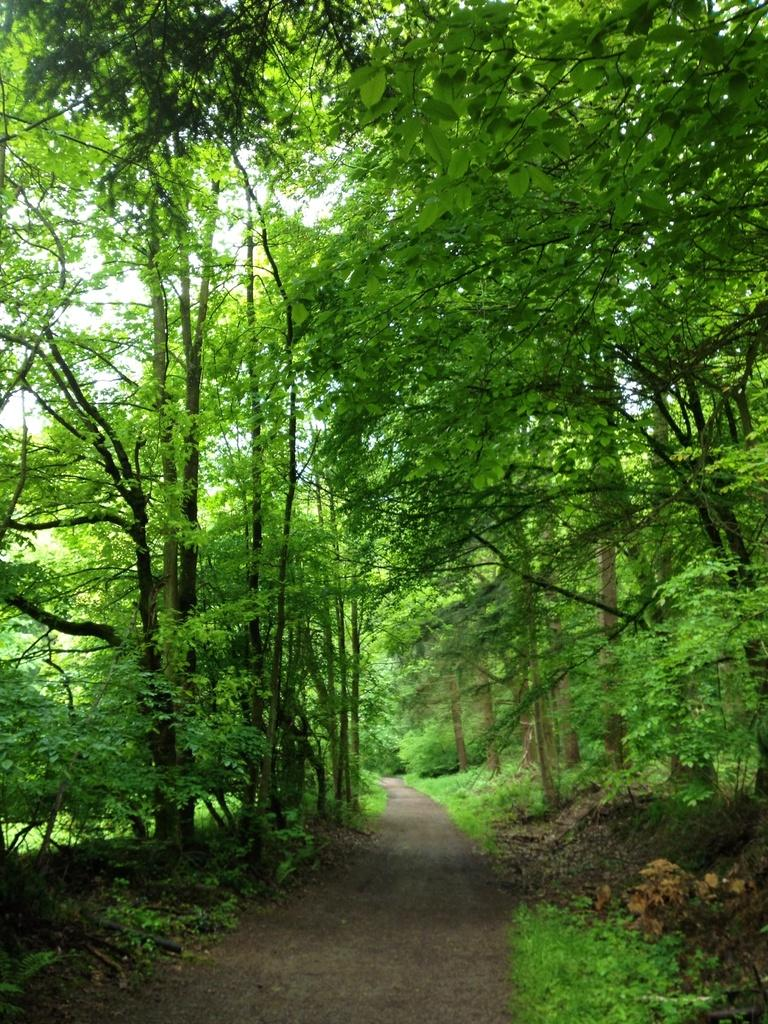What type of vegetation can be seen in the image? There are trees in the image. What else can be seen on the ground in the image? There is grass in the image. What type of man-made structure is visible in the image? There is a road in the image. What type of war is depicted in the image? There is no depiction of war in the image; it features trees, grass, and a road. What is the twist in the image? There is no twist in the image; it is a straightforward representation of trees, grass, and a road. 